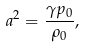<formula> <loc_0><loc_0><loc_500><loc_500>a ^ { 2 } = \frac { \gamma p _ { 0 } } { \rho _ { 0 } } ,</formula> 